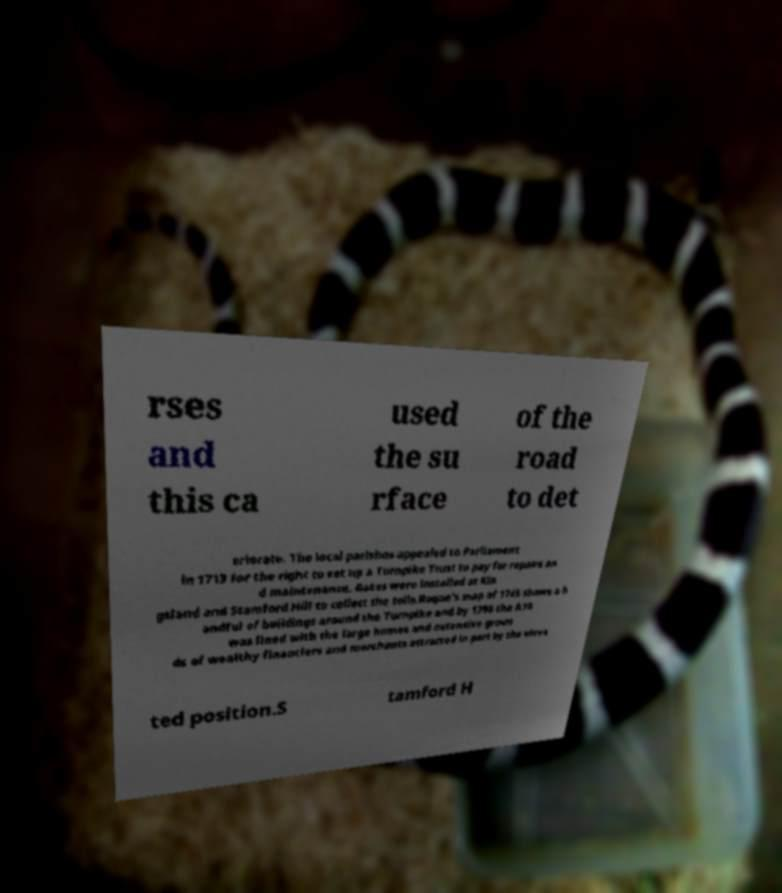Can you accurately transcribe the text from the provided image for me? rses and this ca used the su rface of the road to det eriorate. The local parishes appealed to Parliament in 1713 for the right to set up a Turnpike Trust to pay for repairs an d maintenance. Gates were installed at Kin gsland and Stamford Hill to collect the tolls.Roque's map of 1745 shows a h andful of buildings around the Turnpike and by 1795 the A10 was lined with the large homes and extensive groun ds of wealthy financiers and merchants attracted in part by the eleva ted position.S tamford H 